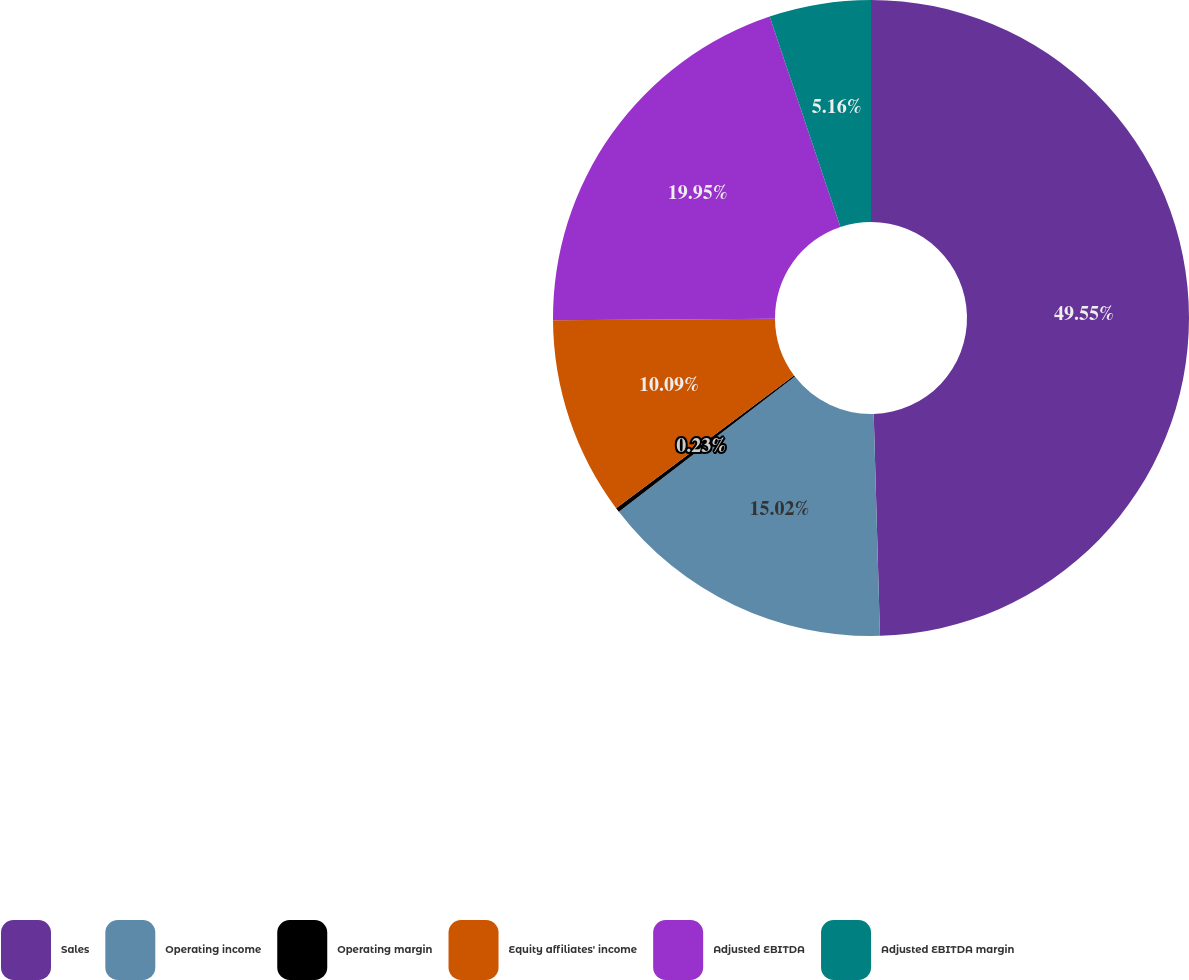Convert chart. <chart><loc_0><loc_0><loc_500><loc_500><pie_chart><fcel>Sales<fcel>Operating income<fcel>Operating margin<fcel>Equity affiliates' income<fcel>Adjusted EBITDA<fcel>Adjusted EBITDA margin<nl><fcel>49.55%<fcel>15.02%<fcel>0.23%<fcel>10.09%<fcel>19.95%<fcel>5.16%<nl></chart> 